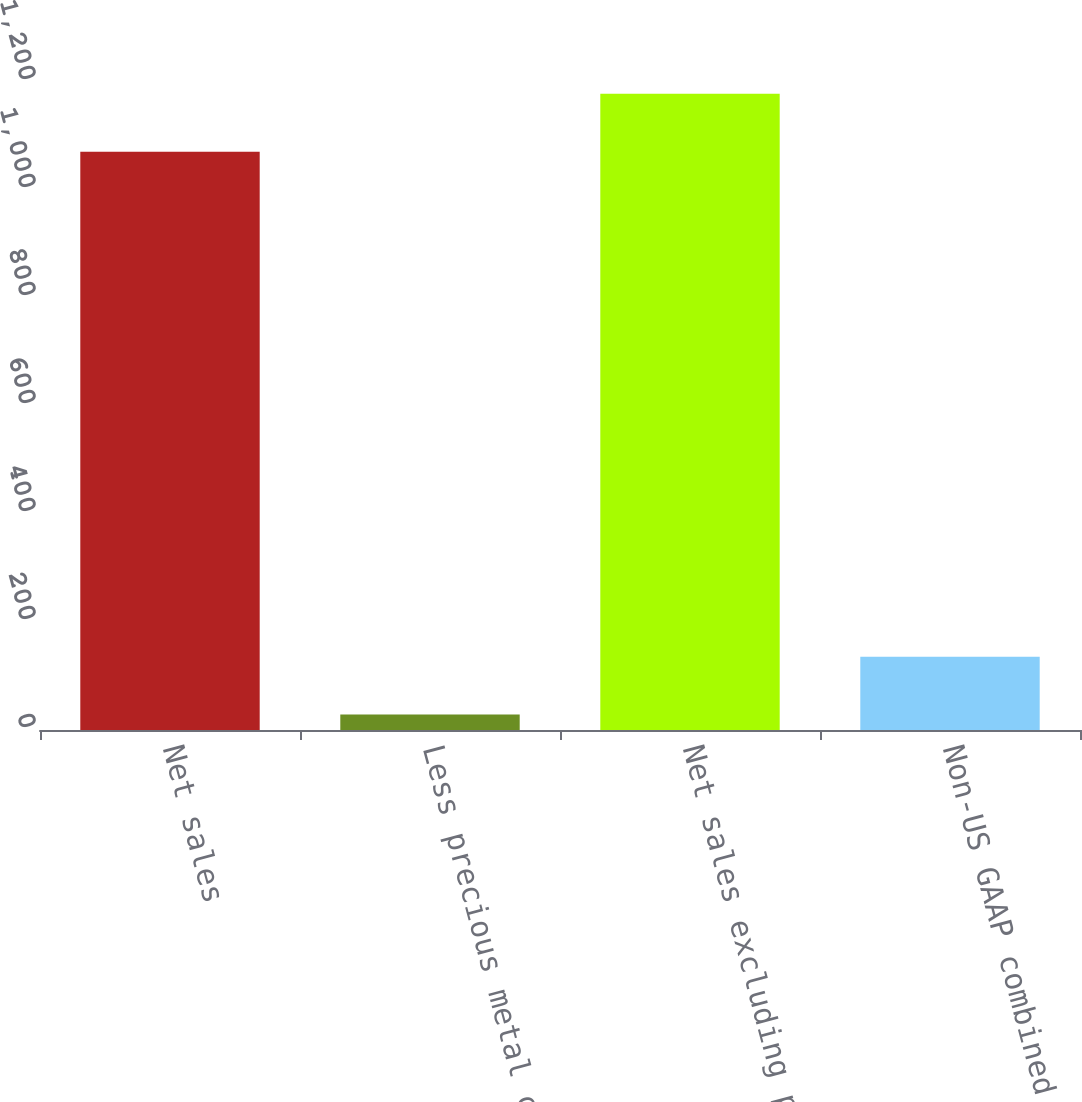<chart> <loc_0><loc_0><loc_500><loc_500><bar_chart><fcel>Net sales<fcel>Less precious metal content of<fcel>Net sales excluding precious<fcel>Non-US GAAP combined business<nl><fcel>1071<fcel>28.5<fcel>1178.1<fcel>135.6<nl></chart> 